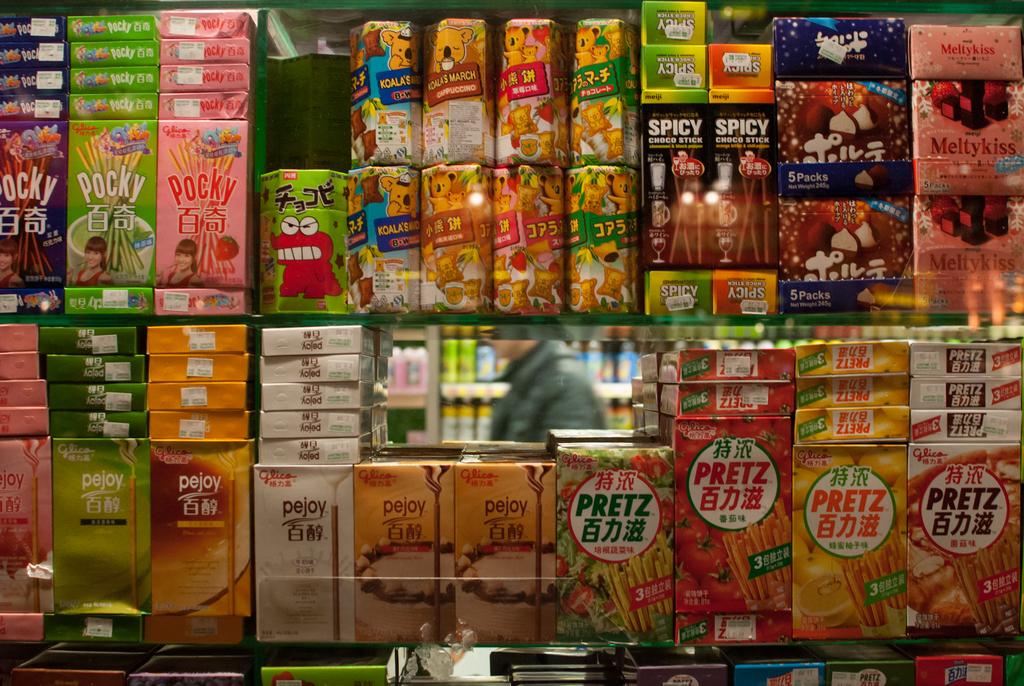What is the name of the snack on the top left?
Offer a very short reply. Pocky. What is the name of the snack on the bottom right?
Keep it short and to the point. Pretz. 